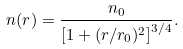<formula> <loc_0><loc_0><loc_500><loc_500>n ( r ) = \frac { n _ { 0 } } { \left [ 1 + ( r / r _ { 0 } ) ^ { 2 } \right ] ^ { 3 / 4 } } .</formula> 